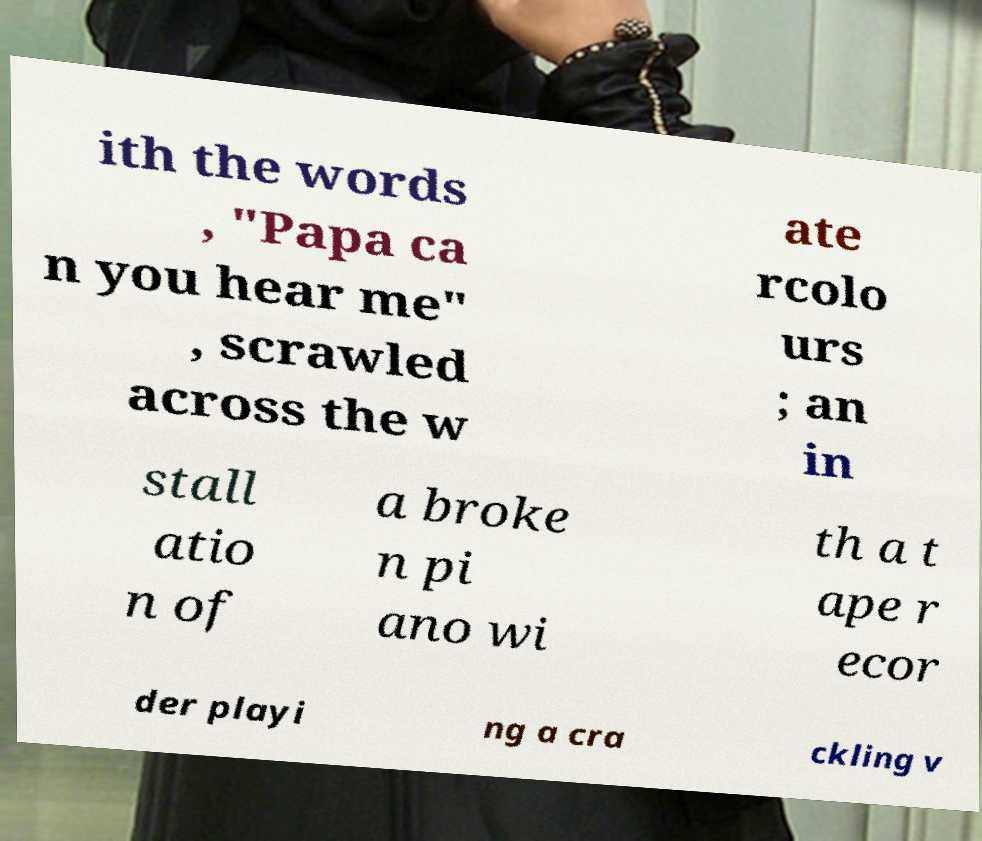I need the written content from this picture converted into text. Can you do that? ith the words , "Papa ca n you hear me" , scrawled across the w ate rcolo urs ; an in stall atio n of a broke n pi ano wi th a t ape r ecor der playi ng a cra ckling v 